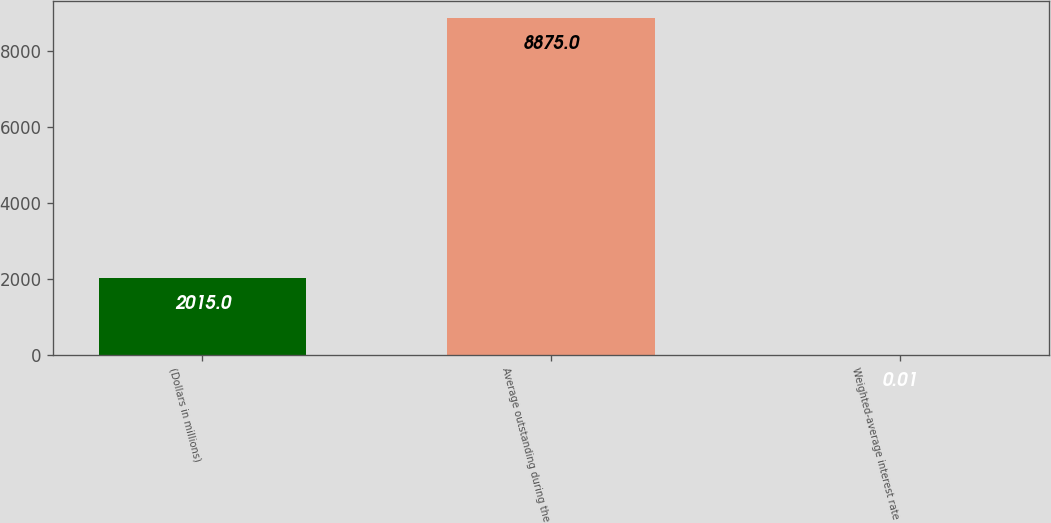<chart> <loc_0><loc_0><loc_500><loc_500><bar_chart><fcel>(Dollars in millions)<fcel>Average outstanding during the<fcel>Weighted-average interest rate<nl><fcel>2015<fcel>8875<fcel>0.01<nl></chart> 